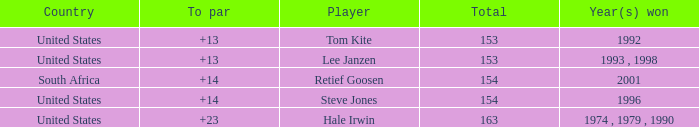Parse the full table. {'header': ['Country', 'To par', 'Player', 'Total', 'Year(s) won'], 'rows': [['United States', '+13', 'Tom Kite', '153', '1992'], ['United States', '+13', 'Lee Janzen', '153', '1993 , 1998'], ['South Africa', '+14', 'Retief Goosen', '154', '2001'], ['United States', '+14', 'Steve Jones', '154', '1996'], ['United States', '+23', 'Hale Irwin', '163', '1974 , 1979 , 1990']]} What is the overall amount that south africa had a par above 14? None. 